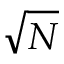<formula> <loc_0><loc_0><loc_500><loc_500>\sqrt { N }</formula> 